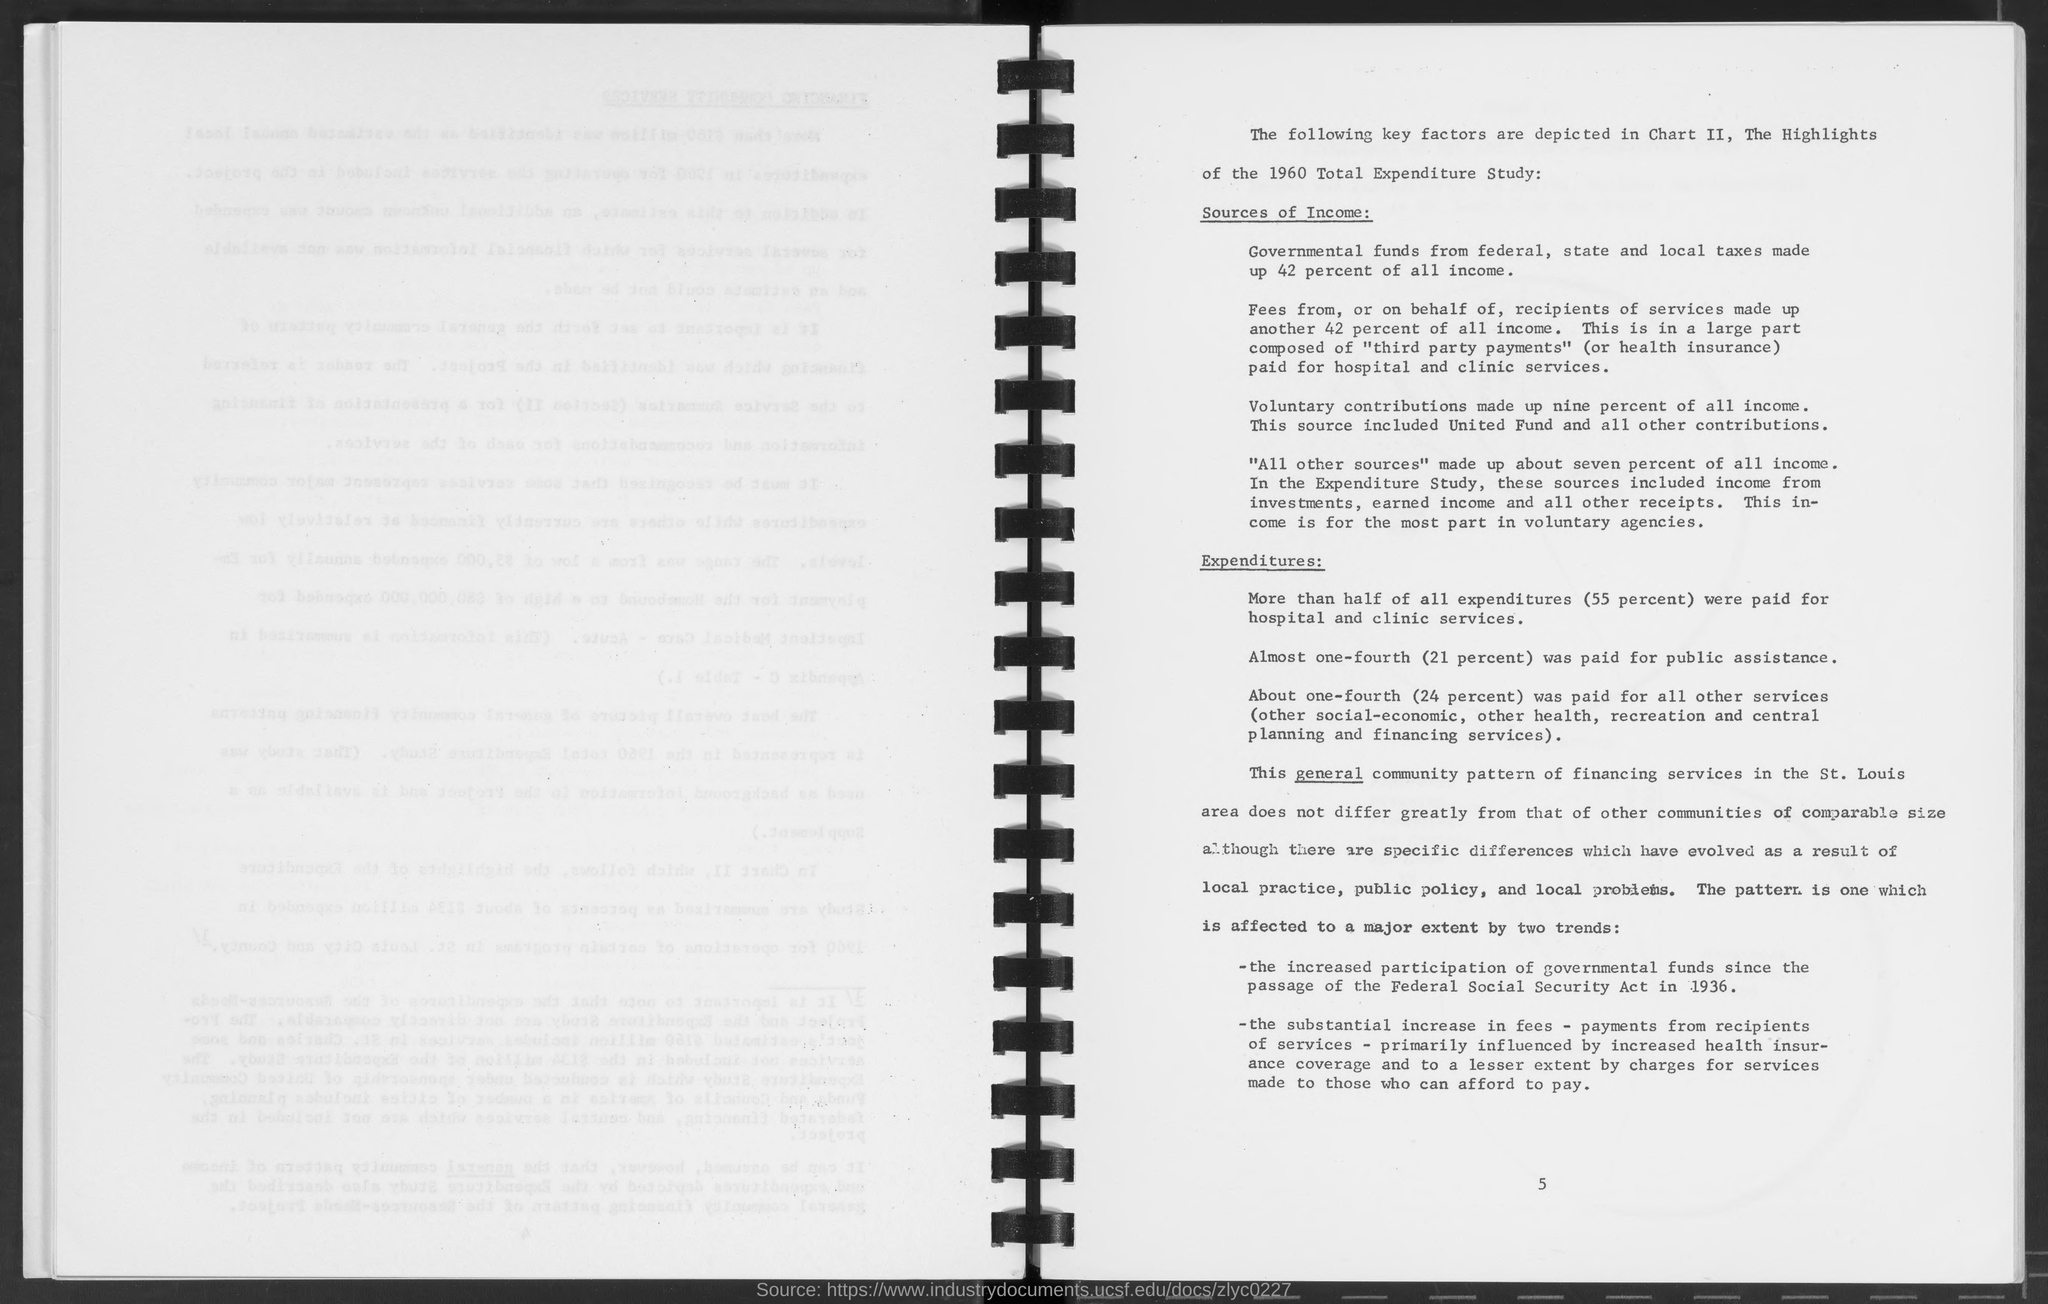What is the number at bottom of the page ?
Provide a short and direct response. 5. 